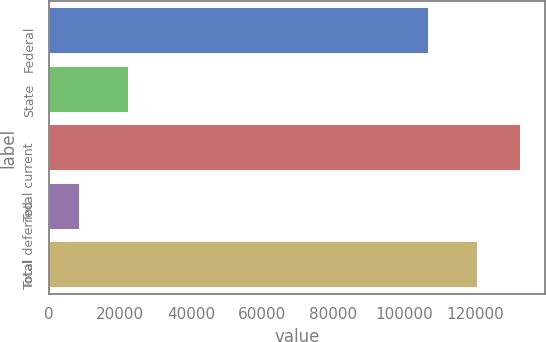<chart> <loc_0><loc_0><loc_500><loc_500><bar_chart><fcel>Federal<fcel>State<fcel>Total current<fcel>Total deferred<fcel>Total<nl><fcel>107083<fcel>22646<fcel>132972<fcel>8845<fcel>120884<nl></chart> 